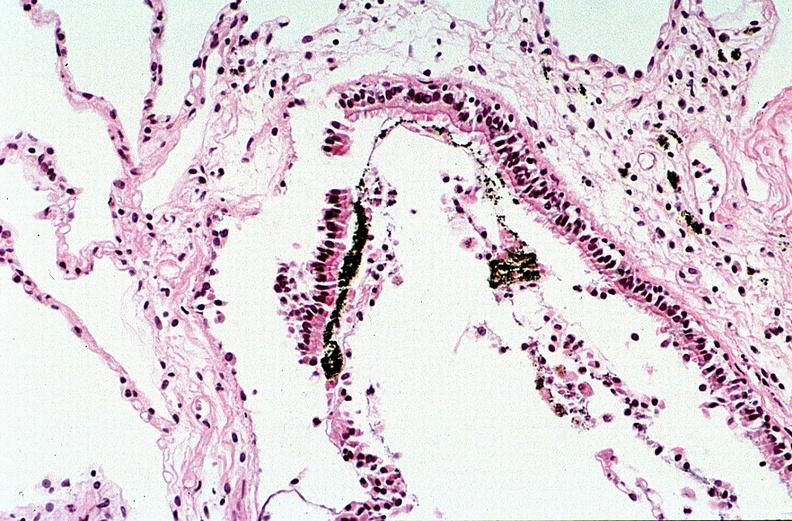s respiratory present?
Answer the question using a single word or phrase. Yes 